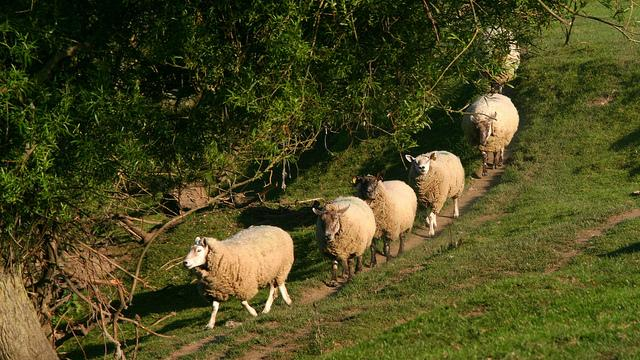What are the animals walking along? Please explain your reasoning. trail. The sheep are going on a path. 